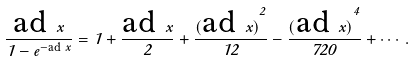Convert formula to latex. <formula><loc_0><loc_0><loc_500><loc_500>\frac { { \text {ad } x } } { 1 - e ^ { - \text {ad } x } } = 1 + \frac { { \text {ad } x } } { 2 } + \frac { { ( \text {ad } x ) } ^ { 2 } } { 1 2 } - \frac { { ( \text {ad } x ) } ^ { 4 } } { 7 2 0 } + \cdots .</formula> 